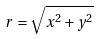Convert formula to latex. <formula><loc_0><loc_0><loc_500><loc_500>r = \sqrt { x ^ { 2 } + y ^ { 2 } }</formula> 